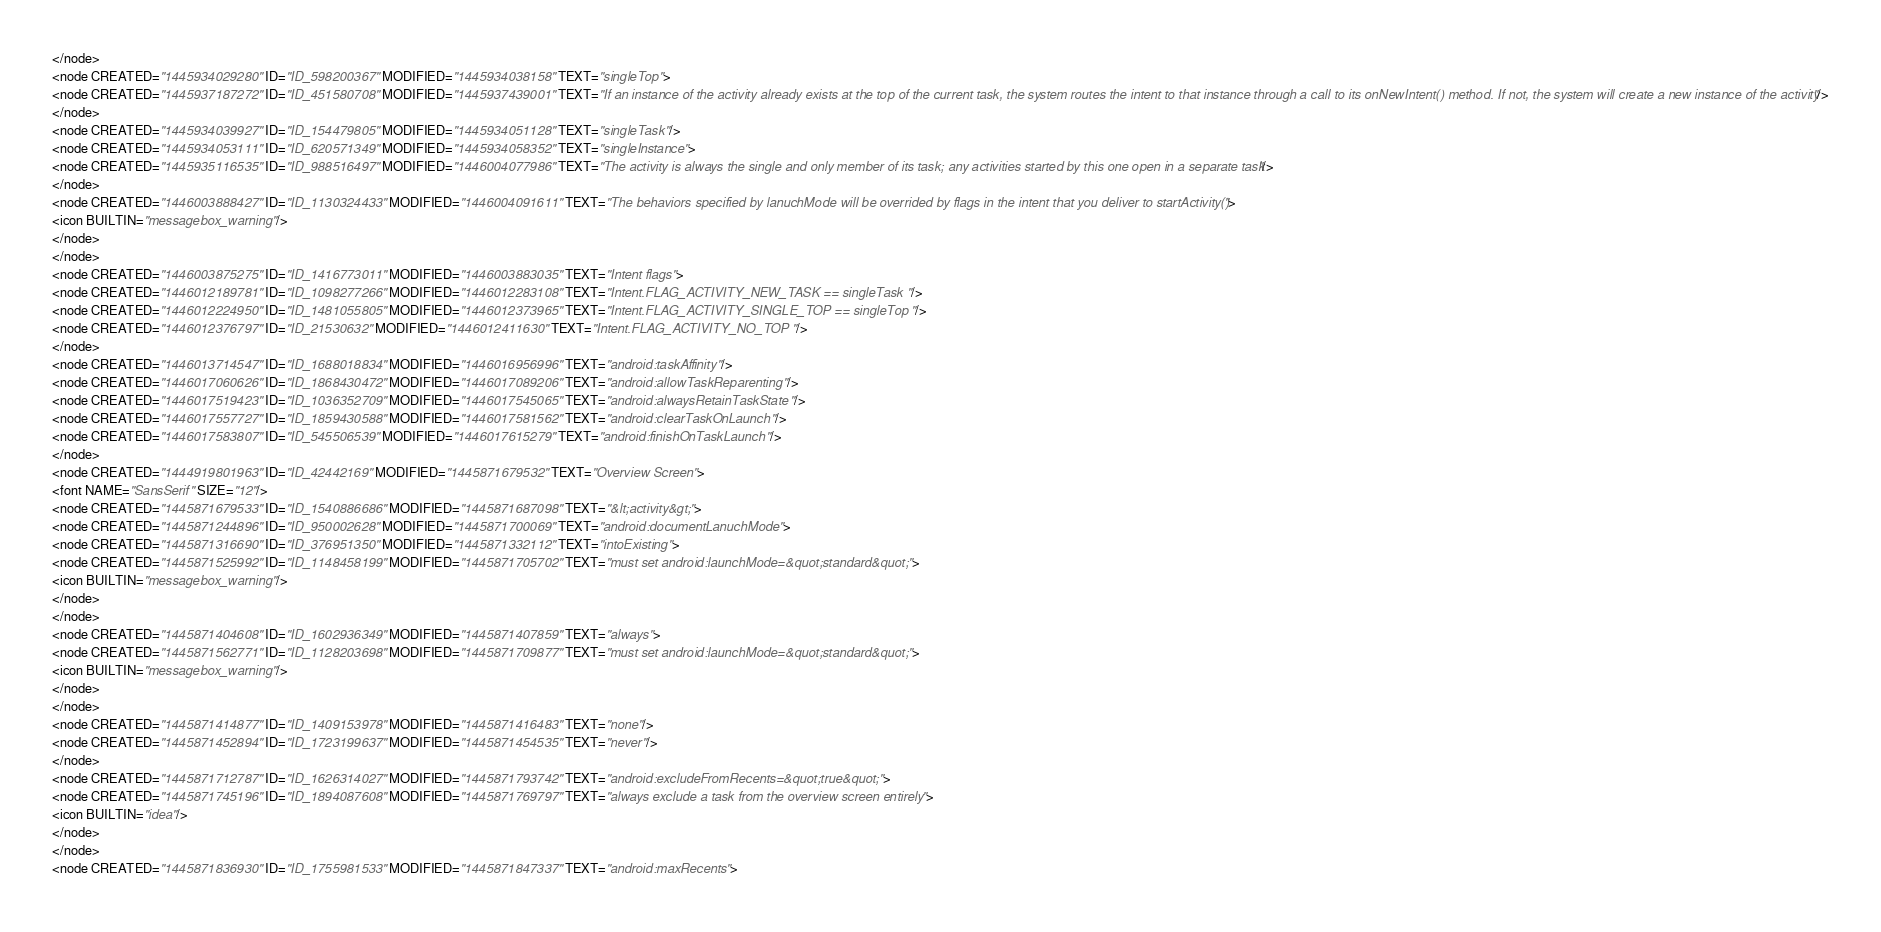Convert code to text. <code><loc_0><loc_0><loc_500><loc_500><_ObjectiveC_></node>
<node CREATED="1445934029280" ID="ID_598200367" MODIFIED="1445934038158" TEXT="singleTop">
<node CREATED="1445937187272" ID="ID_451580708" MODIFIED="1445937439001" TEXT="If an instance of the activity already exists at the top of the current task, the system routes the intent to that instance through a call to its onNewIntent() method. If not, the system will create a new instance of the activity"/>
</node>
<node CREATED="1445934039927" ID="ID_154479805" MODIFIED="1445934051128" TEXT="singleTask"/>
<node CREATED="1445934053111" ID="ID_620571349" MODIFIED="1445934058352" TEXT="singleInstance">
<node CREATED="1445935116535" ID="ID_988516497" MODIFIED="1446004077986" TEXT="The activity is always the single and only member of its task; any activities started by this one open in a separate task"/>
</node>
<node CREATED="1446003888427" ID="ID_1130324433" MODIFIED="1446004091611" TEXT="The behaviors specified by lanuchMode will be overrided by flags in the intent that you deliver to startActivity()">
<icon BUILTIN="messagebox_warning"/>
</node>
</node>
<node CREATED="1446003875275" ID="ID_1416773011" MODIFIED="1446003883035" TEXT="Intent flags">
<node CREATED="1446012189781" ID="ID_1098277266" MODIFIED="1446012283108" TEXT="Intent.FLAG_ACTIVITY_NEW_TASK == singleTask"/>
<node CREATED="1446012224950" ID="ID_1481055805" MODIFIED="1446012373965" TEXT="Intent.FLAG_ACTIVITY_SINGLE_TOP == singleTop"/>
<node CREATED="1446012376797" ID="ID_21530632" MODIFIED="1446012411630" TEXT="Intent.FLAG_ACTIVITY_NO_TOP"/>
</node>
<node CREATED="1446013714547" ID="ID_1688018834" MODIFIED="1446016956996" TEXT="android:taskAffinity"/>
<node CREATED="1446017060626" ID="ID_1868430472" MODIFIED="1446017089206" TEXT="android:allowTaskReparenting"/>
<node CREATED="1446017519423" ID="ID_1036352709" MODIFIED="1446017545065" TEXT="android:alwaysRetainTaskState"/>
<node CREATED="1446017557727" ID="ID_1859430588" MODIFIED="1446017581562" TEXT="android:clearTaskOnLaunch"/>
<node CREATED="1446017583807" ID="ID_545506539" MODIFIED="1446017615279" TEXT="android:finishOnTaskLaunch"/>
</node>
<node CREATED="1444919801963" ID="ID_42442169" MODIFIED="1445871679532" TEXT="Overview Screen">
<font NAME="SansSerif" SIZE="12"/>
<node CREATED="1445871679533" ID="ID_1540886686" MODIFIED="1445871687098" TEXT="&lt;activity&gt;">
<node CREATED="1445871244896" ID="ID_950002628" MODIFIED="1445871700069" TEXT="android:documentLanuchMode">
<node CREATED="1445871316690" ID="ID_376951350" MODIFIED="1445871332112" TEXT="intoExisting">
<node CREATED="1445871525992" ID="ID_1148458199" MODIFIED="1445871705702" TEXT="must set android:launchMode=&quot;standard&quot;">
<icon BUILTIN="messagebox_warning"/>
</node>
</node>
<node CREATED="1445871404608" ID="ID_1602936349" MODIFIED="1445871407859" TEXT="always">
<node CREATED="1445871562771" ID="ID_1128203698" MODIFIED="1445871709877" TEXT="must set android:launchMode=&quot;standard&quot;">
<icon BUILTIN="messagebox_warning"/>
</node>
</node>
<node CREATED="1445871414877" ID="ID_1409153978" MODIFIED="1445871416483" TEXT="none"/>
<node CREATED="1445871452894" ID="ID_1723199637" MODIFIED="1445871454535" TEXT="never"/>
</node>
<node CREATED="1445871712787" ID="ID_1626314027" MODIFIED="1445871793742" TEXT="android:excludeFromRecents=&quot;true&quot;">
<node CREATED="1445871745196" ID="ID_1894087608" MODIFIED="1445871769797" TEXT="always exclude a task from the overview screen entirely">
<icon BUILTIN="idea"/>
</node>
</node>
<node CREATED="1445871836930" ID="ID_1755981533" MODIFIED="1445871847337" TEXT="android:maxRecents"></code> 